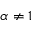Convert formula to latex. <formula><loc_0><loc_0><loc_500><loc_500>\alpha \neq 1</formula> 